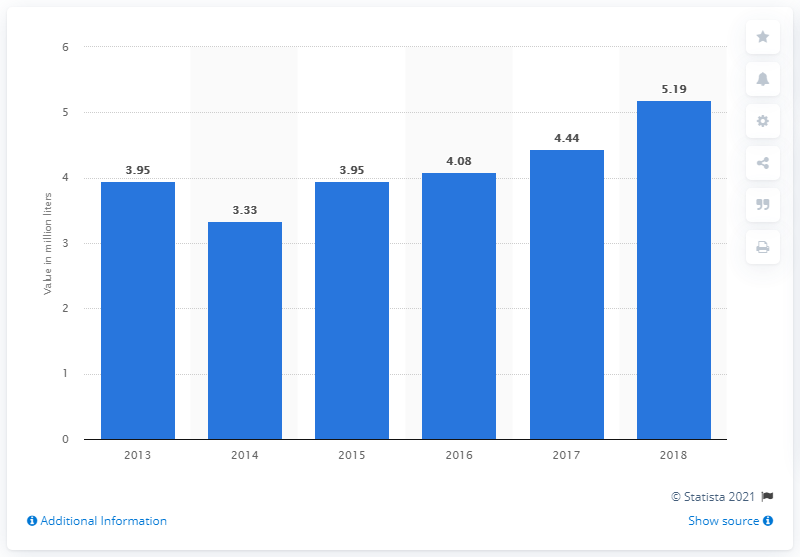Draw attention to some important aspects in this diagram. In 2018, India imported 5.19 billion liters of wine. 